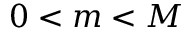Convert formula to latex. <formula><loc_0><loc_0><loc_500><loc_500>0 < m < M</formula> 